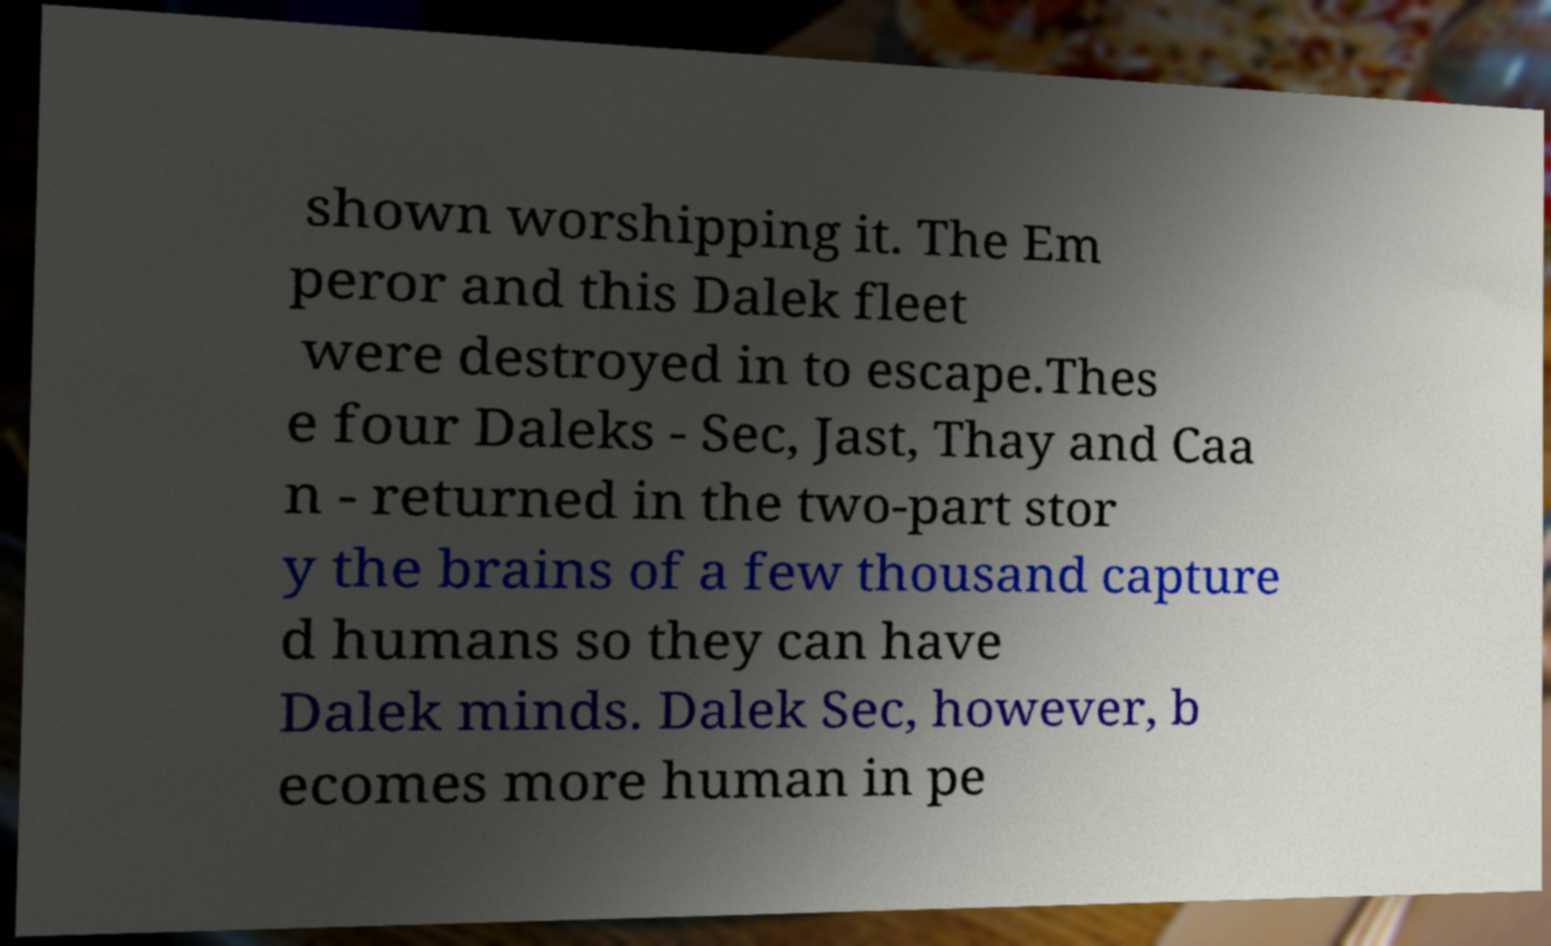I need the written content from this picture converted into text. Can you do that? shown worshipping it. The Em peror and this Dalek fleet were destroyed in to escape.Thes e four Daleks - Sec, Jast, Thay and Caa n - returned in the two-part stor y the brains of a few thousand capture d humans so they can have Dalek minds. Dalek Sec, however, b ecomes more human in pe 